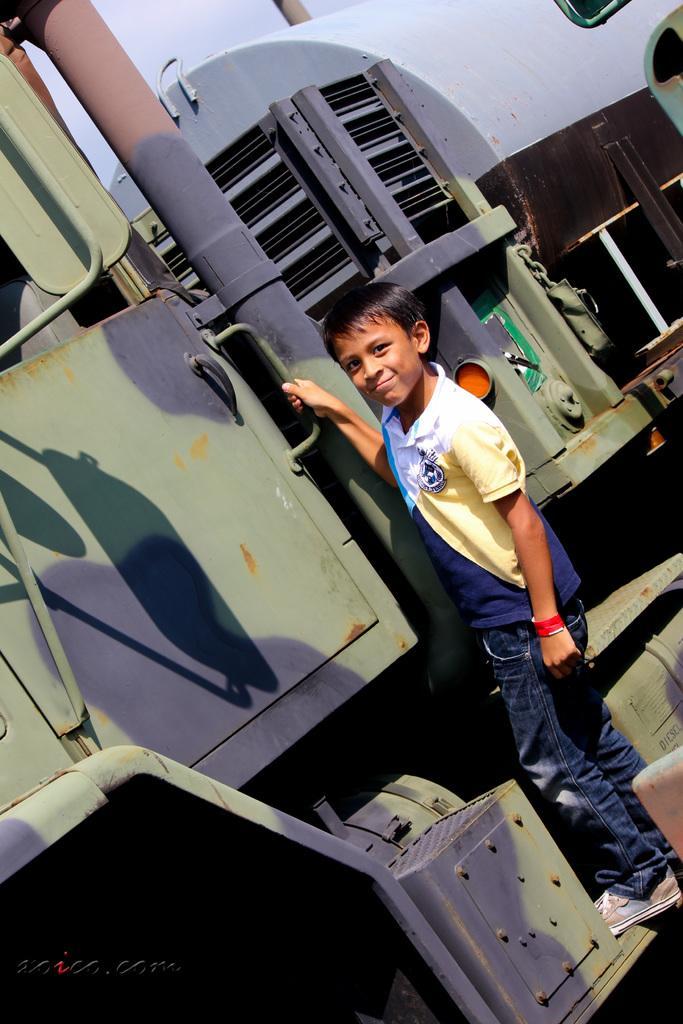How would you summarize this image in a sentence or two? In this image we can see a child wearing t-shirt, jeans and shoes is standing on the train and smiling. 